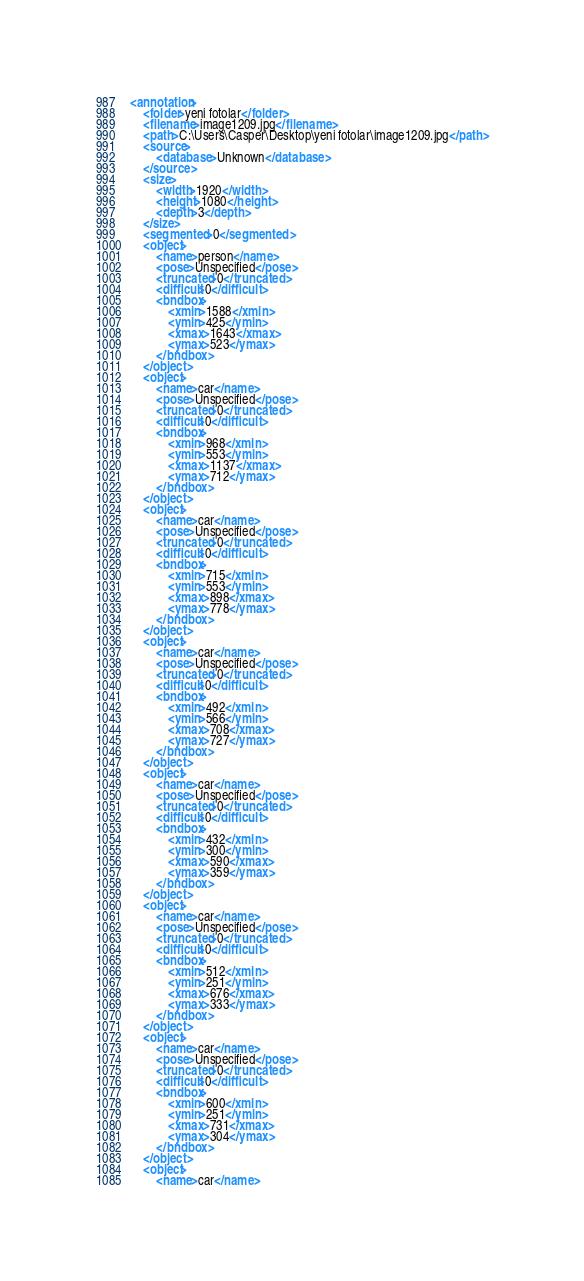<code> <loc_0><loc_0><loc_500><loc_500><_XML_><annotation>
	<folder>yeni fotolar</folder>
	<filename>image1209.jpg</filename>
	<path>C:\Users\Casper\Desktop\yeni fotolar\image1209.jpg</path>
	<source>
		<database>Unknown</database>
	</source>
	<size>
		<width>1920</width>
		<height>1080</height>
		<depth>3</depth>
	</size>
	<segmented>0</segmented>
	<object>
		<name>person</name>
		<pose>Unspecified</pose>
		<truncated>0</truncated>
		<difficult>0</difficult>
		<bndbox>
			<xmin>1588</xmin>
			<ymin>425</ymin>
			<xmax>1643</xmax>
			<ymax>523</ymax>
		</bndbox>
	</object>
	<object>
		<name>car</name>
		<pose>Unspecified</pose>
		<truncated>0</truncated>
		<difficult>0</difficult>
		<bndbox>
			<xmin>968</xmin>
			<ymin>553</ymin>
			<xmax>1137</xmax>
			<ymax>712</ymax>
		</bndbox>
	</object>
	<object>
		<name>car</name>
		<pose>Unspecified</pose>
		<truncated>0</truncated>
		<difficult>0</difficult>
		<bndbox>
			<xmin>715</xmin>
			<ymin>553</ymin>
			<xmax>898</xmax>
			<ymax>778</ymax>
		</bndbox>
	</object>
	<object>
		<name>car</name>
		<pose>Unspecified</pose>
		<truncated>0</truncated>
		<difficult>0</difficult>
		<bndbox>
			<xmin>492</xmin>
			<ymin>566</ymin>
			<xmax>708</xmax>
			<ymax>727</ymax>
		</bndbox>
	</object>
	<object>
		<name>car</name>
		<pose>Unspecified</pose>
		<truncated>0</truncated>
		<difficult>0</difficult>
		<bndbox>
			<xmin>432</xmin>
			<ymin>300</ymin>
			<xmax>590</xmax>
			<ymax>359</ymax>
		</bndbox>
	</object>
	<object>
		<name>car</name>
		<pose>Unspecified</pose>
		<truncated>0</truncated>
		<difficult>0</difficult>
		<bndbox>
			<xmin>512</xmin>
			<ymin>251</ymin>
			<xmax>676</xmax>
			<ymax>333</ymax>
		</bndbox>
	</object>
	<object>
		<name>car</name>
		<pose>Unspecified</pose>
		<truncated>0</truncated>
		<difficult>0</difficult>
		<bndbox>
			<xmin>600</xmin>
			<ymin>251</ymin>
			<xmax>731</xmax>
			<ymax>304</ymax>
		</bndbox>
	</object>
	<object>
		<name>car</name></code> 